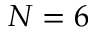<formula> <loc_0><loc_0><loc_500><loc_500>N = 6</formula> 